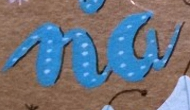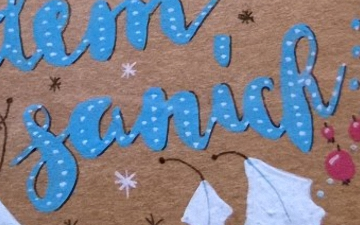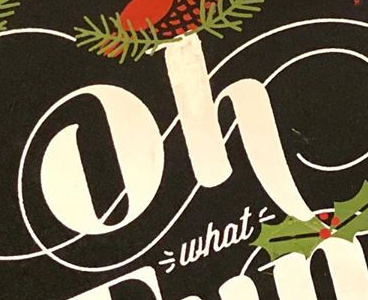What text appears in these images from left to right, separated by a semicolon? na; sanick; oh 